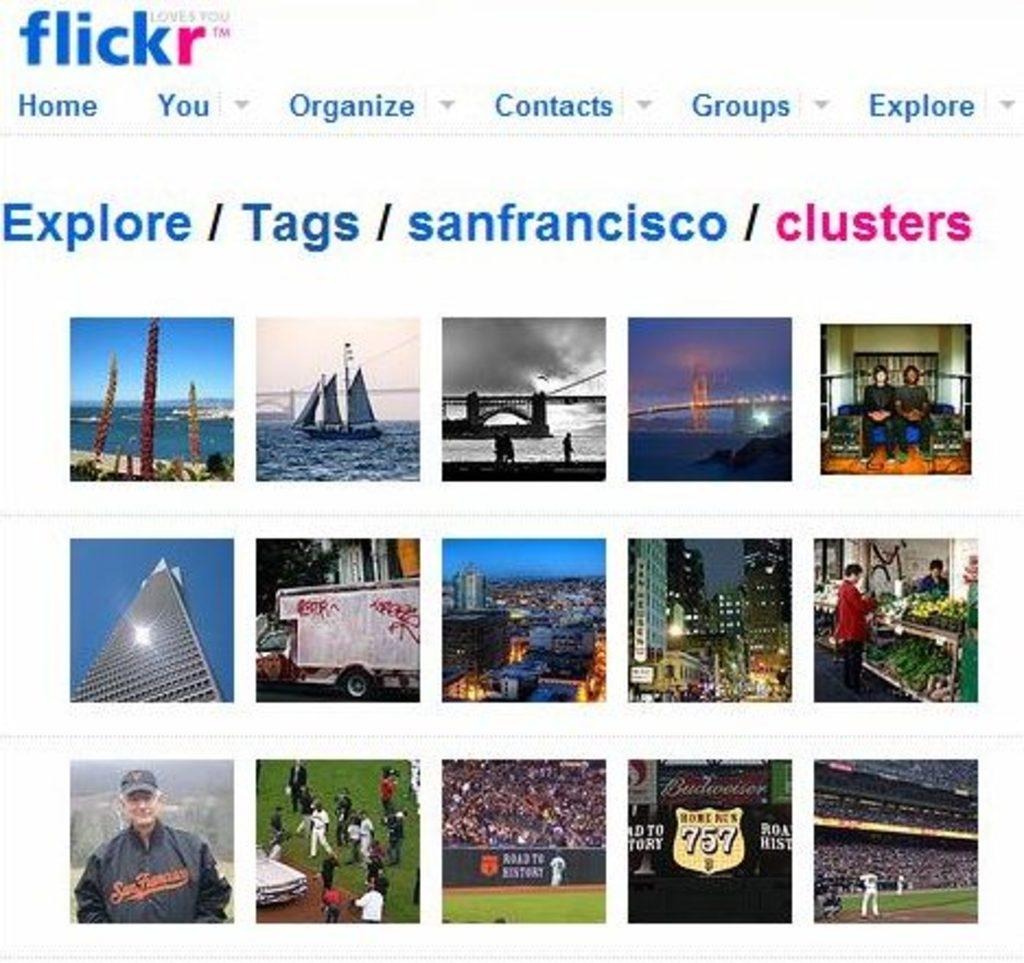What type of content is displayed in the image? The image contains a website page. Can you describe any natural elements visible in the image? There is water visible in the image. What type of structure can be seen in the image? There is a bridge in the image. Are there any people present in the image? Yes, there are people in the image. What type of man-made structures are visible in the image? There are buildings in the image. What type of recreational area is present in the image? There is a playground in the image. What is written at the top of the image? There is written text at the top of the image. Can you see any nests in the image? There are no nests visible in the image. What type of flight is taking place in the image? There is no flight present in the image. 